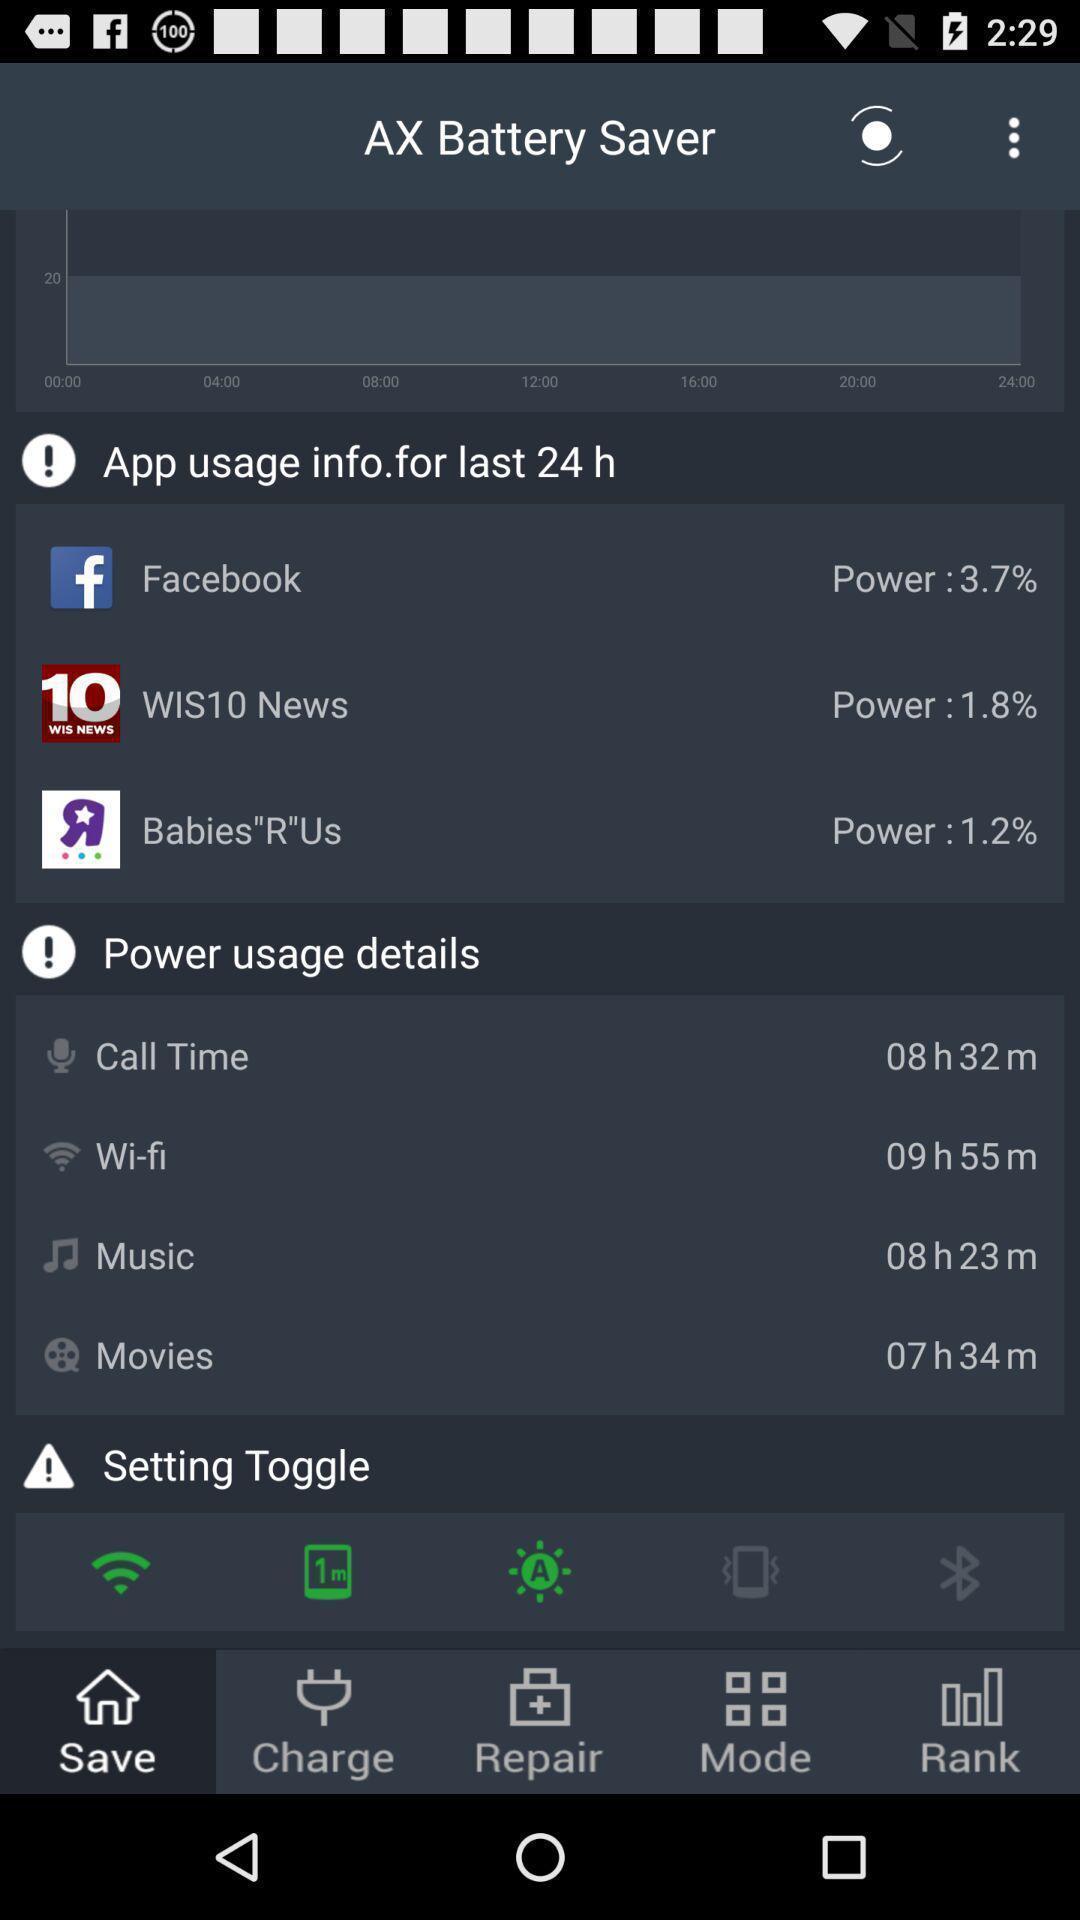Summarize the main components in this picture. Screen displaying the battery saver page. 